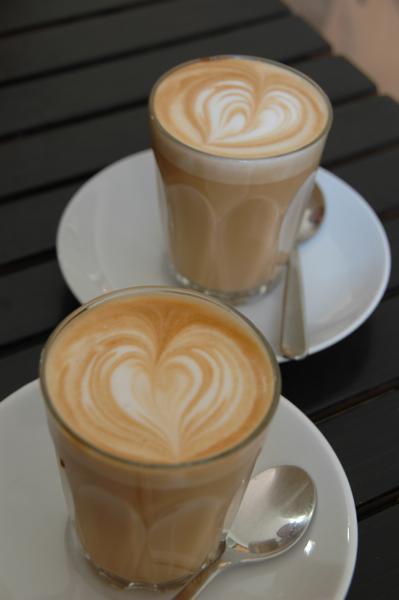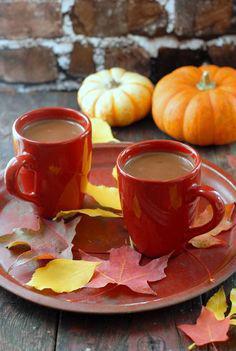The first image is the image on the left, the second image is the image on the right. Considering the images on both sides, is "Two of the mugs are set on one tray." valid? Answer yes or no. Yes. The first image is the image on the left, the second image is the image on the right. For the images shown, is this caption "Each image shows two matching hot drinks in cups, one of the pairs, cups of coffee with heart shaped froth designs." true? Answer yes or no. Yes. 